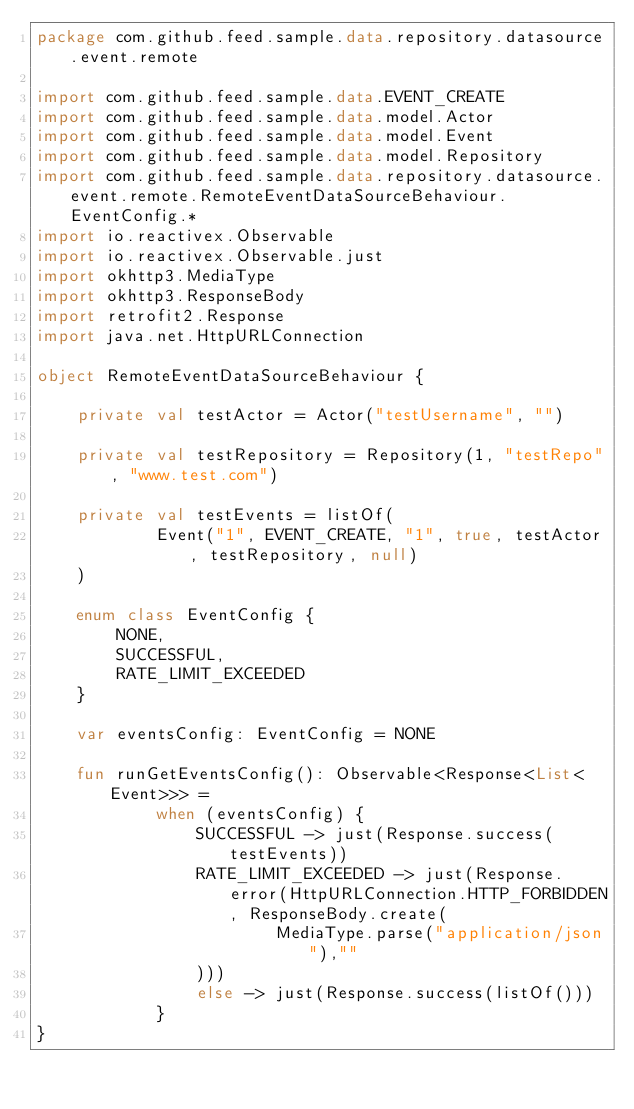Convert code to text. <code><loc_0><loc_0><loc_500><loc_500><_Kotlin_>package com.github.feed.sample.data.repository.datasource.event.remote

import com.github.feed.sample.data.EVENT_CREATE
import com.github.feed.sample.data.model.Actor
import com.github.feed.sample.data.model.Event
import com.github.feed.sample.data.model.Repository
import com.github.feed.sample.data.repository.datasource.event.remote.RemoteEventDataSourceBehaviour.EventConfig.*
import io.reactivex.Observable
import io.reactivex.Observable.just
import okhttp3.MediaType
import okhttp3.ResponseBody
import retrofit2.Response
import java.net.HttpURLConnection

object RemoteEventDataSourceBehaviour {

    private val testActor = Actor("testUsername", "")

    private val testRepository = Repository(1, "testRepo", "www.test.com")

    private val testEvents = listOf(
            Event("1", EVENT_CREATE, "1", true, testActor, testRepository, null)
    )

    enum class EventConfig {
        NONE,
        SUCCESSFUL,
        RATE_LIMIT_EXCEEDED
    }

    var eventsConfig: EventConfig = NONE

    fun runGetEventsConfig(): Observable<Response<List<Event>>> =
            when (eventsConfig) {
                SUCCESSFUL -> just(Response.success(testEvents))
                RATE_LIMIT_EXCEEDED -> just(Response.error(HttpURLConnection.HTTP_FORBIDDEN, ResponseBody.create(
                        MediaType.parse("application/json"),""
                )))
                else -> just(Response.success(listOf()))
            }
}
</code> 